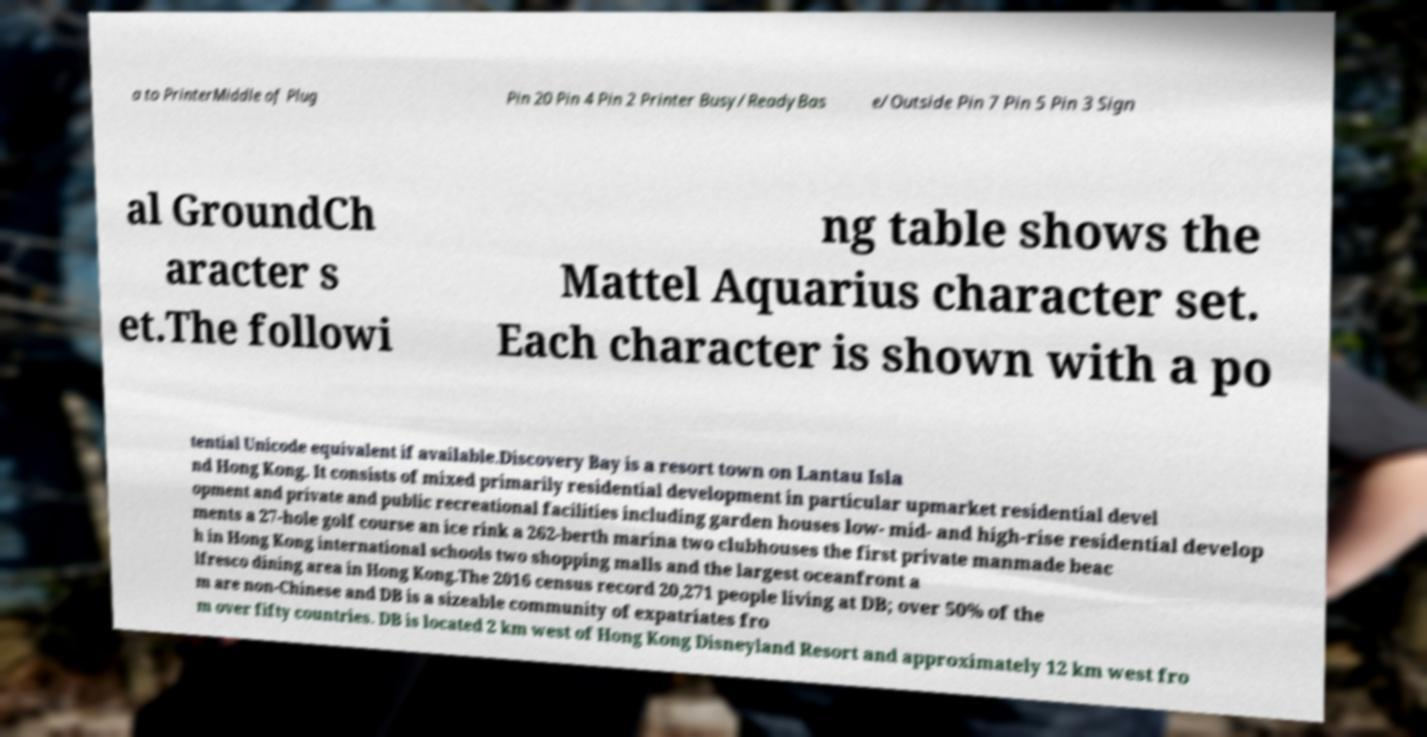Could you assist in decoding the text presented in this image and type it out clearly? a to PrinterMiddle of Plug Pin 20 Pin 4 Pin 2 Printer Busy/ReadyBas e/Outside Pin 7 Pin 5 Pin 3 Sign al GroundCh aracter s et.The followi ng table shows the Mattel Aquarius character set. Each character is shown with a po tential Unicode equivalent if available.Discovery Bay is a resort town on Lantau Isla nd Hong Kong. It consists of mixed primarily residential development in particular upmarket residential devel opment and private and public recreational facilities including garden houses low- mid- and high-rise residential develop ments a 27-hole golf course an ice rink a 262-berth marina two clubhouses the first private manmade beac h in Hong Kong international schools two shopping malls and the largest oceanfront a lfresco dining area in Hong Kong.The 2016 census record 20,271 people living at DB; over 50% of the m are non-Chinese and DB is a sizeable community of expatriates fro m over fifty countries. DB is located 2 km west of Hong Kong Disneyland Resort and approximately 12 km west fro 